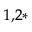<formula> <loc_0><loc_0><loc_500><loc_500>^ { 1 , 2 * }</formula> 